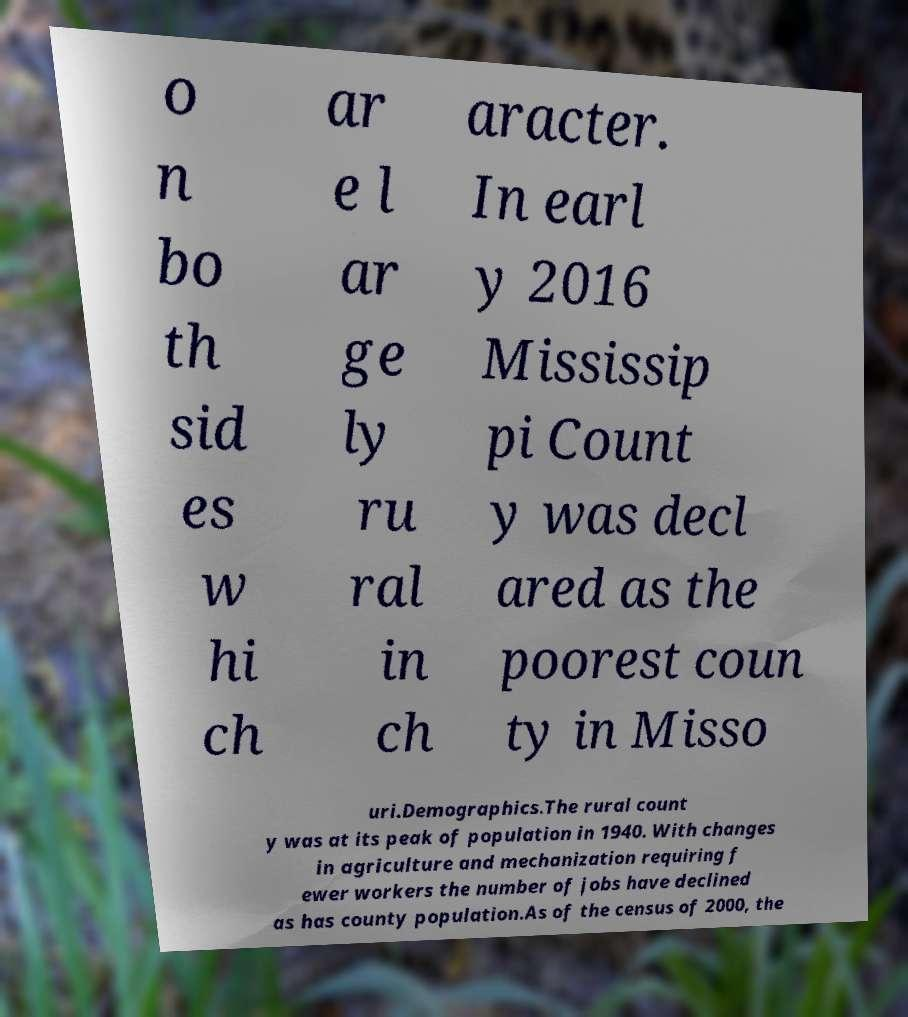Can you accurately transcribe the text from the provided image for me? o n bo th sid es w hi ch ar e l ar ge ly ru ral in ch aracter. In earl y 2016 Mississip pi Count y was decl ared as the poorest coun ty in Misso uri.Demographics.The rural count y was at its peak of population in 1940. With changes in agriculture and mechanization requiring f ewer workers the number of jobs have declined as has county population.As of the census of 2000, the 